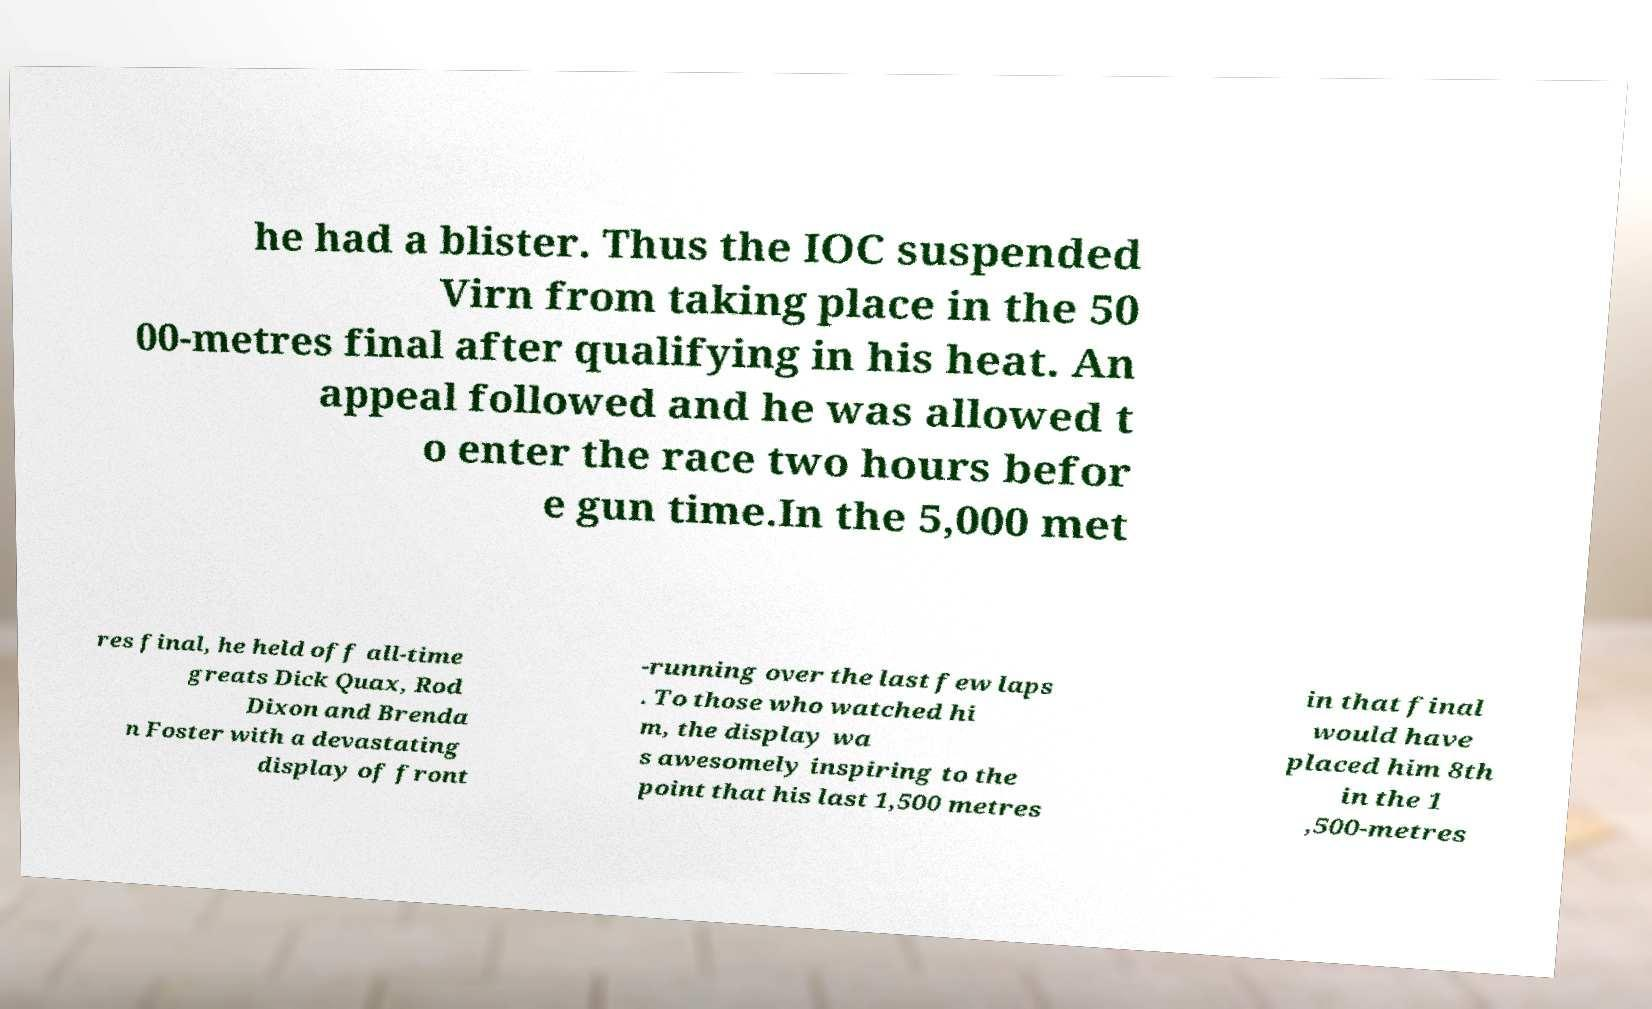There's text embedded in this image that I need extracted. Can you transcribe it verbatim? he had a blister. Thus the IOC suspended Virn from taking place in the 50 00-metres final after qualifying in his heat. An appeal followed and he was allowed t o enter the race two hours befor e gun time.In the 5,000 met res final, he held off all-time greats Dick Quax, Rod Dixon and Brenda n Foster with a devastating display of front -running over the last few laps . To those who watched hi m, the display wa s awesomely inspiring to the point that his last 1,500 metres in that final would have placed him 8th in the 1 ,500-metres 